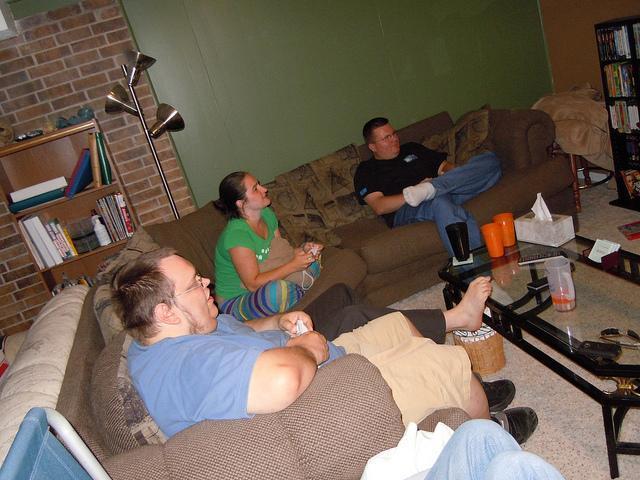How many people in this photo are sitting Indian-style?
Give a very brief answer. 1. How many dining tables are visible?
Give a very brief answer. 1. How many people are visible?
Give a very brief answer. 4. 